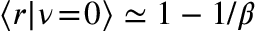<formula> <loc_0><loc_0><loc_500><loc_500>\left \langle r | d l e | \nu \, = \, 0 \right \rangle \simeq 1 - 1 / \beta</formula> 